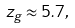Convert formula to latex. <formula><loc_0><loc_0><loc_500><loc_500>z _ { g } \approx 5 . 7 ,</formula> 